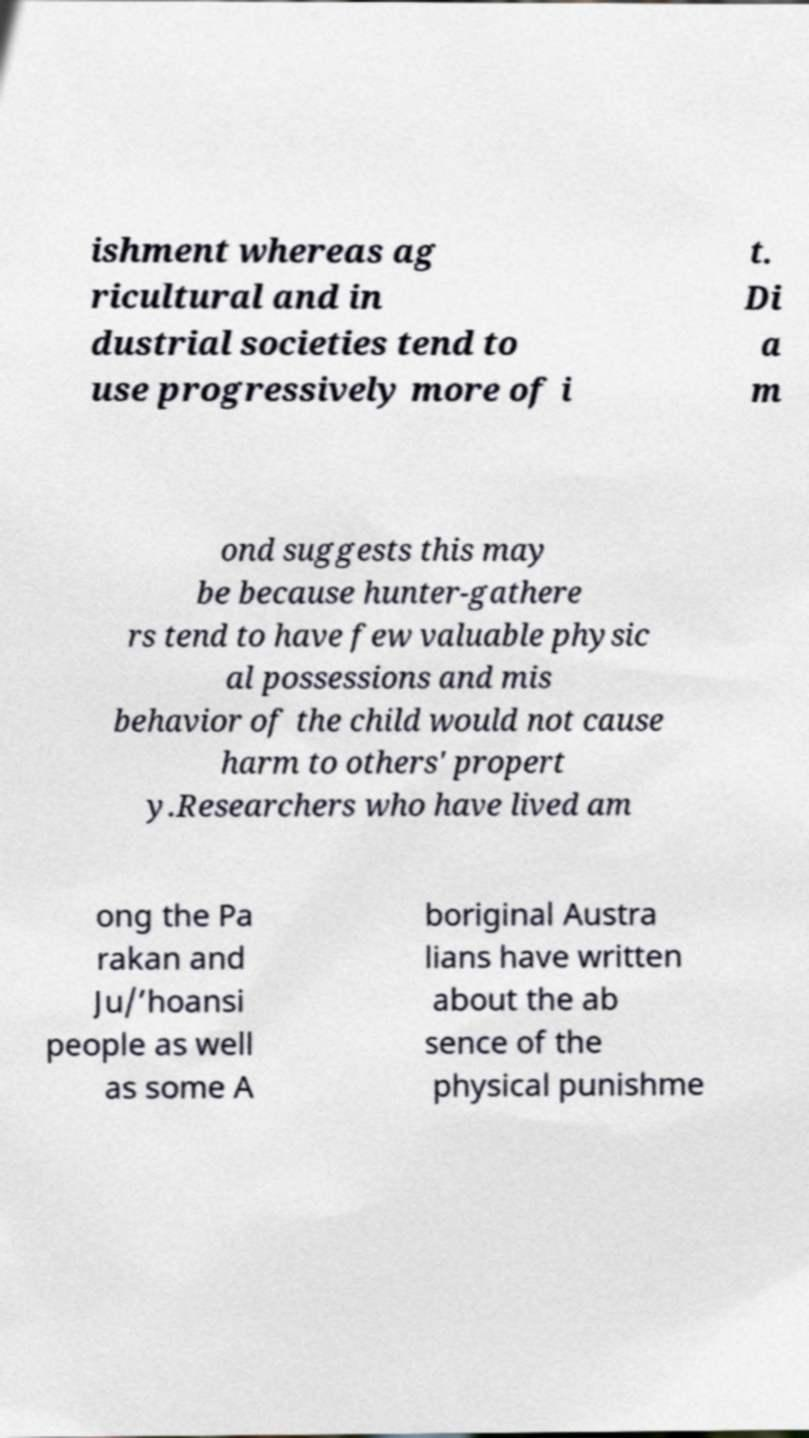Could you extract and type out the text from this image? ishment whereas ag ricultural and in dustrial societies tend to use progressively more of i t. Di a m ond suggests this may be because hunter-gathere rs tend to have few valuable physic al possessions and mis behavior of the child would not cause harm to others' propert y.Researchers who have lived am ong the Pa rakan and Ju/’hoansi people as well as some A boriginal Austra lians have written about the ab sence of the physical punishme 